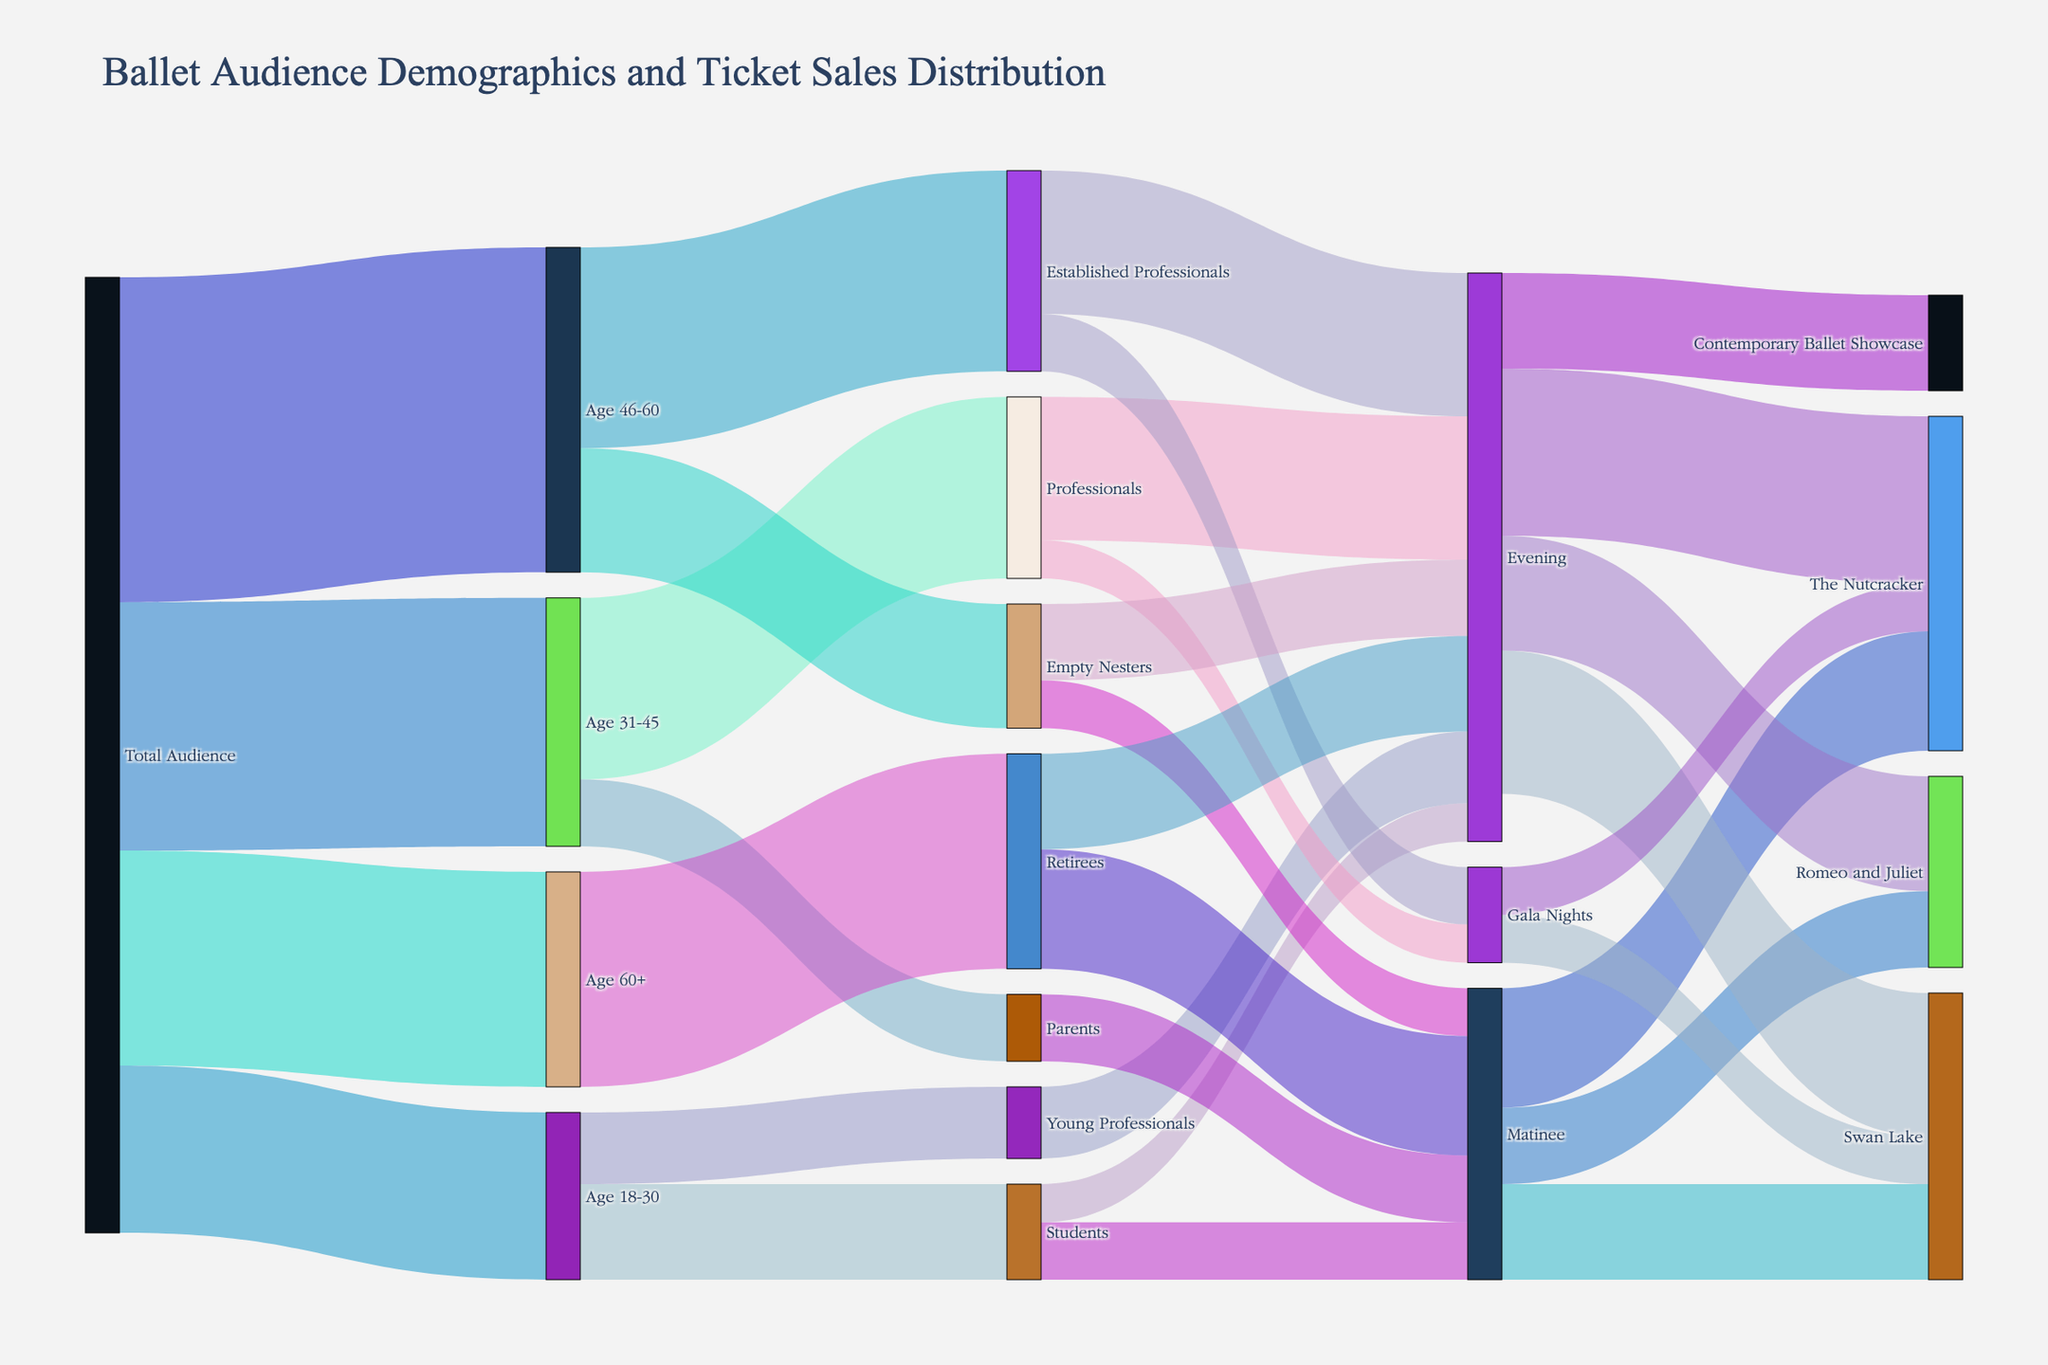What is the title of the figure? The title of the figure is usually located at the top. In this figure, the title is "Ballet Audience Demographics and Ticket Sales Distribution".
Answer: Ballet Audience Demographics and Ticket Sales Distribution How many age groups are shown as part of the total audience? We need to count all the distinct age groups that are connected directly to "Total Audience". Those groups are Age 18-30, Age 31-45, Age 46-60, and Age 60+.
Answer: 4 How many audience members are categorized under Age 31-45? We look at the flow directly connecting "Total Audience" to "Age 31-45". The value attached to this flow is 5200.
Answer: 5200 How many ticket sales are attributed to the "Evening" performance category in total? We need to sum all the values directed towards "Evening". The flows are from Students (800), Young Professionals (1500), Professionals (3000), Established Professionals (3000), Empty Nesters (1600), and Retirees (2000). The total is 800 + 1500 + 3000 + 3000 + 1600 + 2000 = 11900.
Answer: 11900 How many attendees who are "Parents" are there, and how are they distributed across performance times? We have to find the flow from "Age 31-45" to "Parents" and then see its subsequent flows. "Parents" total is 1400, all connected to "Matinee".
Answer: 1400; all to Matinee Which performance type (Matinee, Evening, Gala Nights) has the largest share of "Swan Lake" ticket sales? We need to check the sales under "Swan Lake" from Matinee (2000), Evening (3000), and Gala Nights (1000). Evening is highest with 3000.
Answer: Evening Compare total ticket sales for "The Nutcracker" and "Romeo and Juliet". Which one is higher and by how much? Sum the sales for "The Nutcracker" from Matinee (2500), Evening (3500), and Gala Nights (1000) to get 7000. Sum the sales for "Romeo and Juliet" from Matinee (1600) and Evening (2400) to get 4000. "The Nutcracker" sales are higher by 7000 - 4000 = 3000.
Answer: The Nutcracker; by 3000 What proportion of "Students" attended the "Matinee" over the total students attending any performance? The total students attending are the sum of those attending Matinee (1200) and Evening (800). The proportion of Matinee attendees is 1200 / (1200 + 800). Converting to proportion: 1200 / 2000 = 0.6 (or 60%).
Answer: 60% Are "Empty Nesters" more likely to attend "Matinee" or "Evening" performances? Check the flows from "Empty Nesters" to Matinee (1000) and Evening (1600). "Evening" has a higher value.
Answer: Evening 